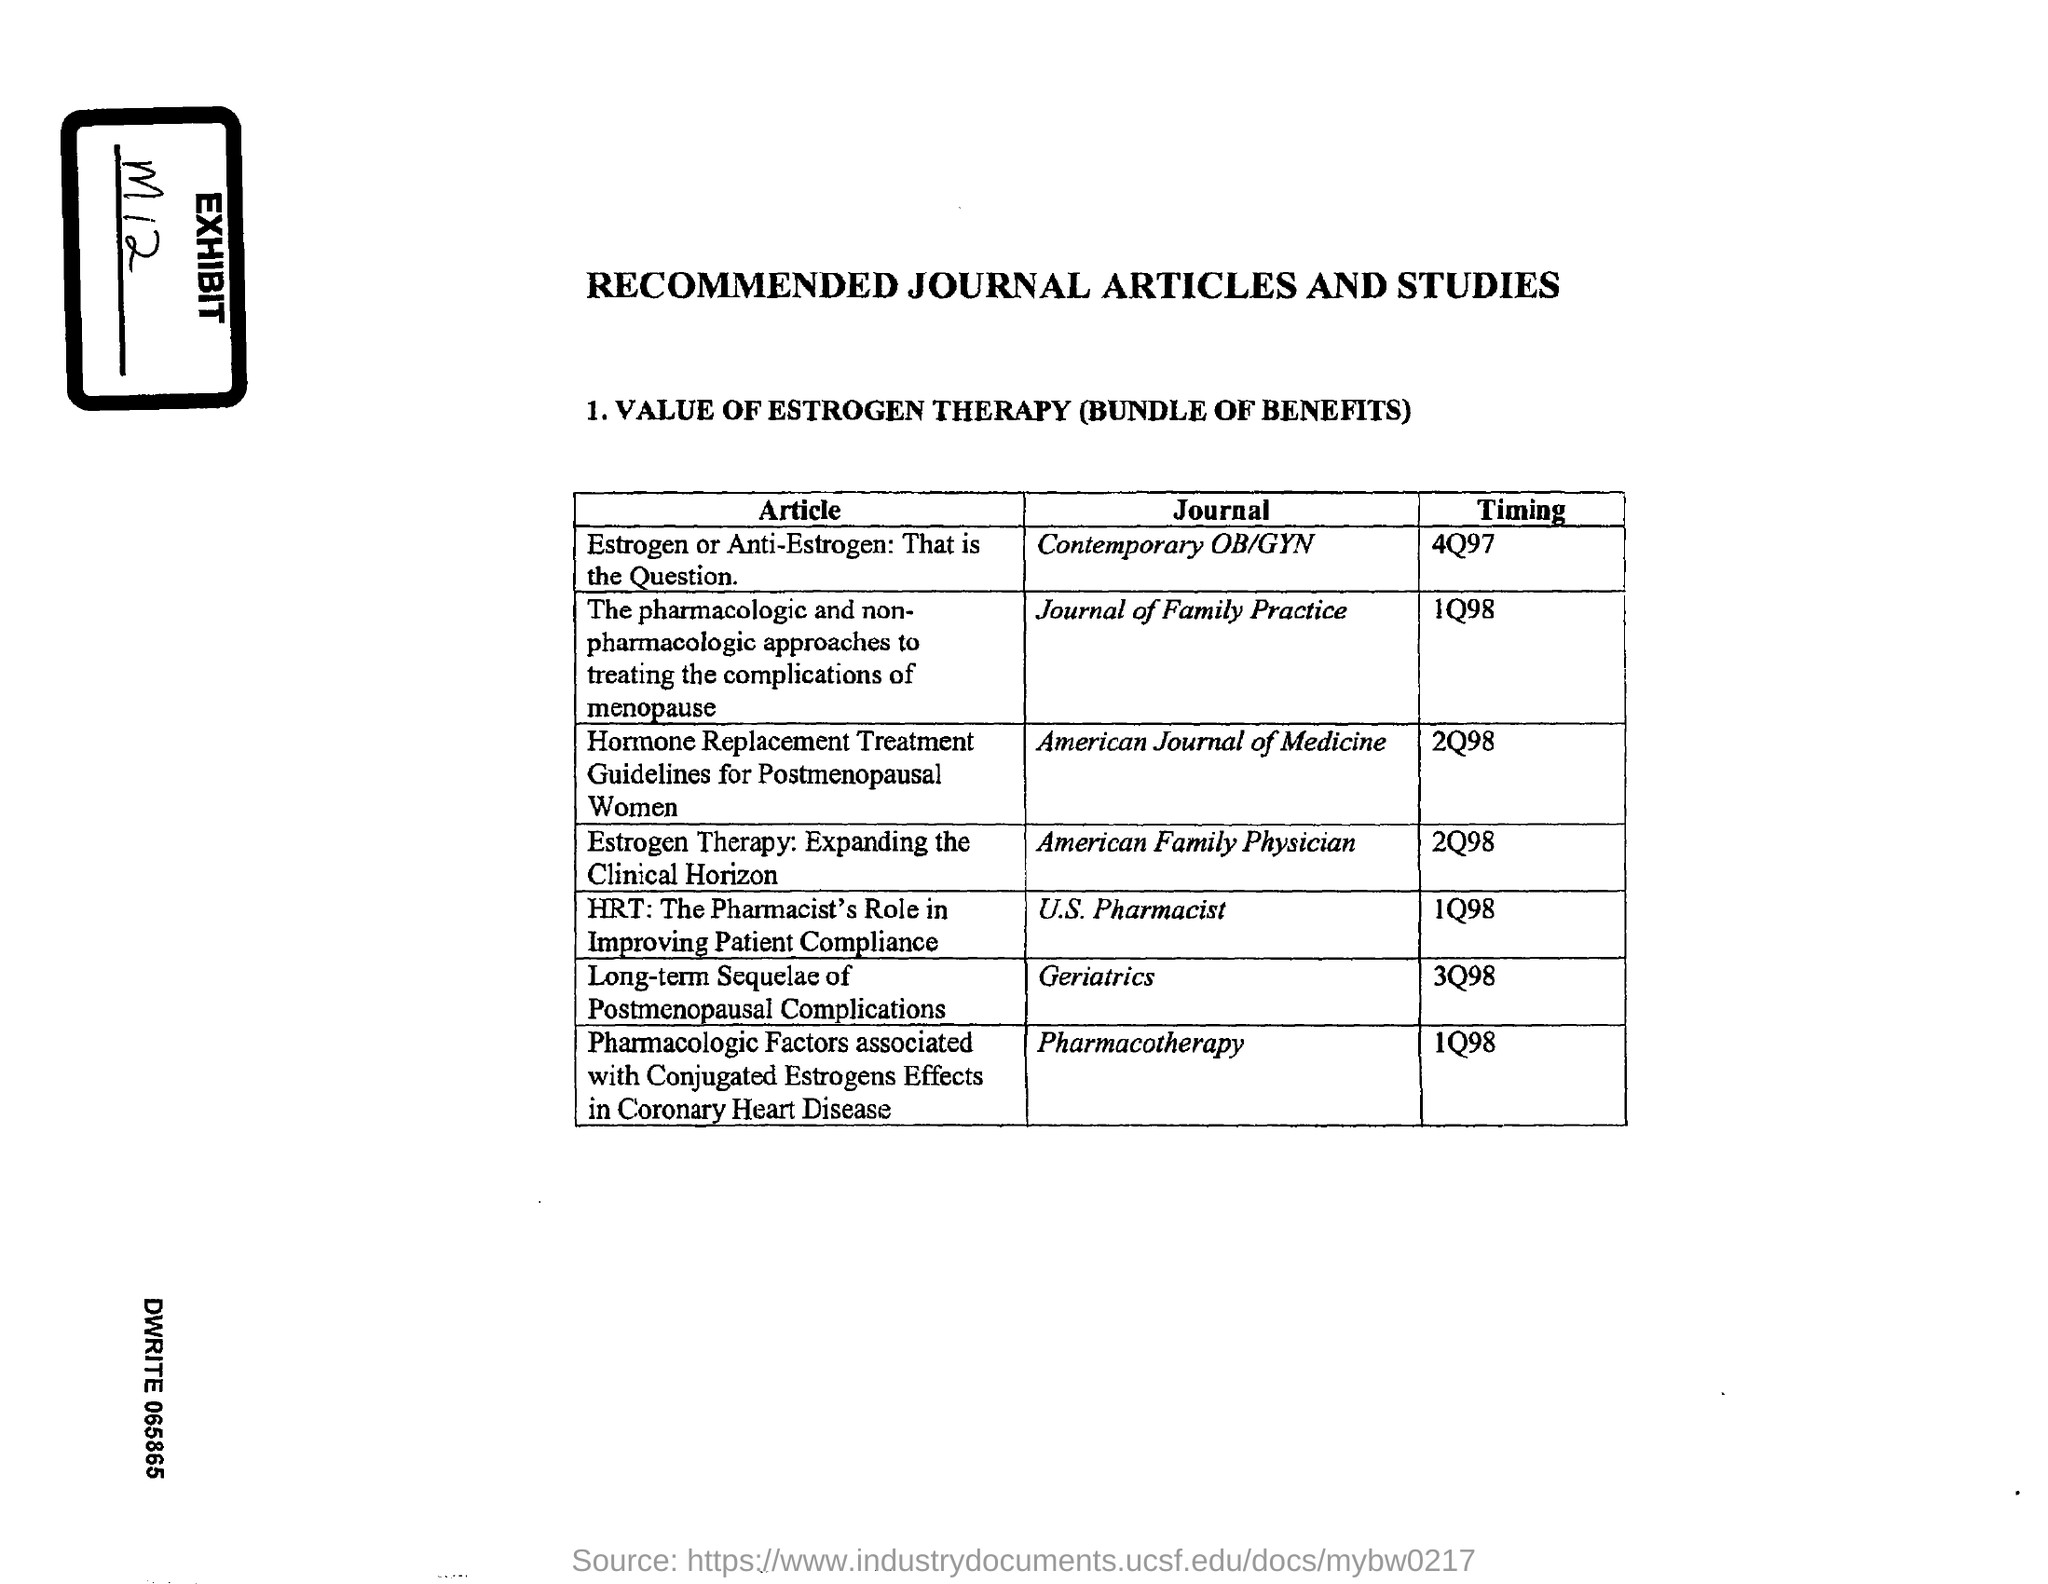What is the Exhibit No mentioned in the document?
Offer a very short reply. M12. Which article is published in the 'Contemporary OB/GYN' journal?
Your answer should be very brief. Estrogen or Anti-Estrogen: That is the Question. In which journal, the article titled 'Estrogen Therapy: Expanding the Clinical Horizon' is published?
Offer a very short reply. American family physician. What is the timing mentioned for the article titled 'Estrogen Therapy: Expanding the Clinical Horizon'?
Make the answer very short. 2Q98. In which journal , the article titled 'Long-term Sequelae of Postmenopausal Complications' is published?
Ensure brevity in your answer.  Geriatrics. What is the timing mentioned for the article titled 'Estrogen or Anti-Estrogen: That is the Question.'?
Give a very brief answer. 4Q97. 